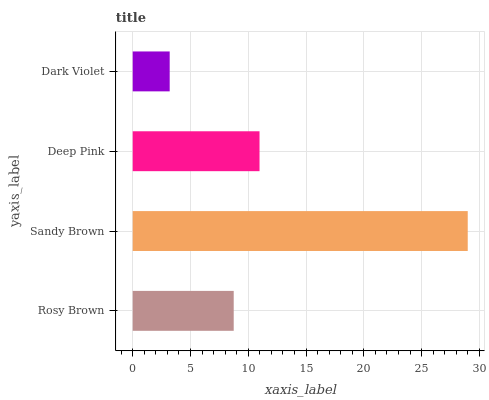Is Dark Violet the minimum?
Answer yes or no. Yes. Is Sandy Brown the maximum?
Answer yes or no. Yes. Is Deep Pink the minimum?
Answer yes or no. No. Is Deep Pink the maximum?
Answer yes or no. No. Is Sandy Brown greater than Deep Pink?
Answer yes or no. Yes. Is Deep Pink less than Sandy Brown?
Answer yes or no. Yes. Is Deep Pink greater than Sandy Brown?
Answer yes or no. No. Is Sandy Brown less than Deep Pink?
Answer yes or no. No. Is Deep Pink the high median?
Answer yes or no. Yes. Is Rosy Brown the low median?
Answer yes or no. Yes. Is Sandy Brown the high median?
Answer yes or no. No. Is Dark Violet the low median?
Answer yes or no. No. 